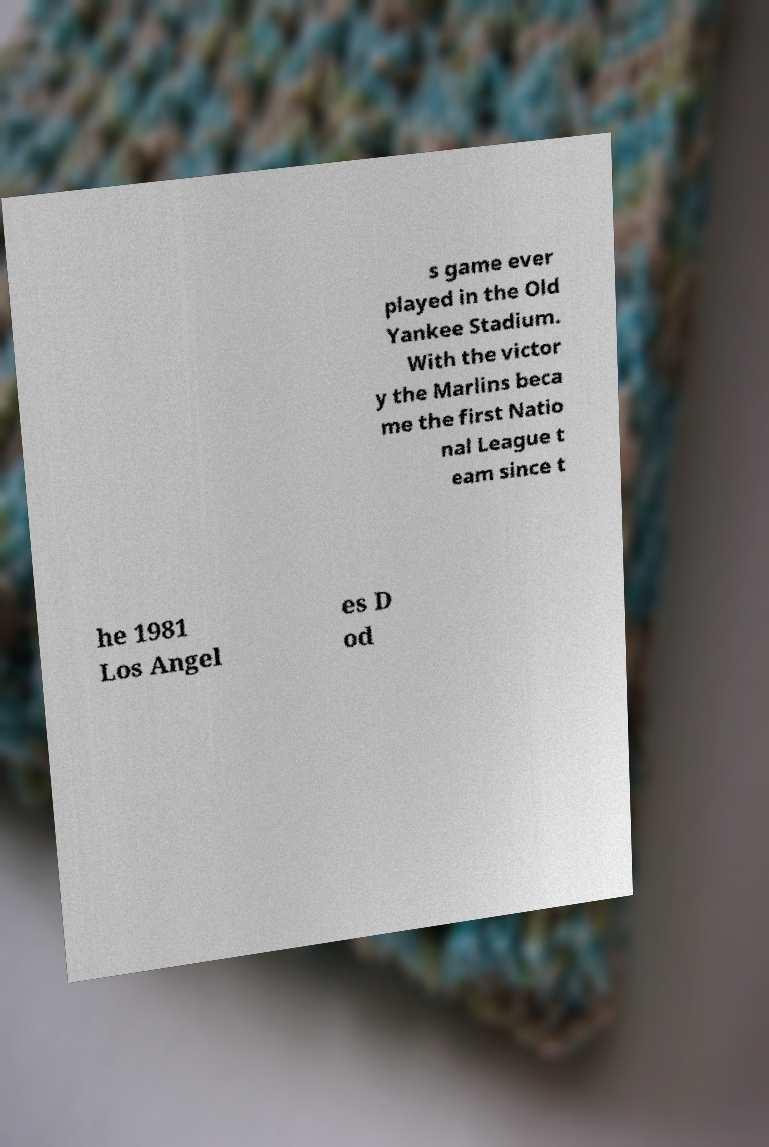Can you read and provide the text displayed in the image?This photo seems to have some interesting text. Can you extract and type it out for me? s game ever played in the Old Yankee Stadium. With the victor y the Marlins beca me the first Natio nal League t eam since t he 1981 Los Angel es D od 